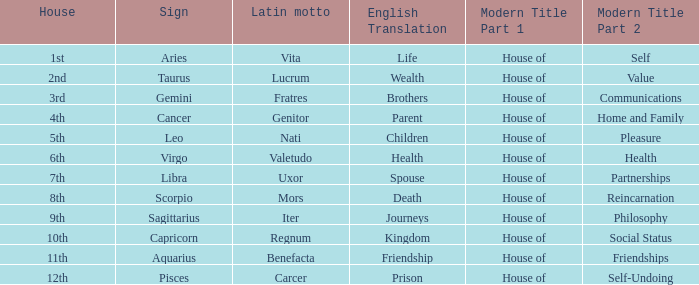Which sign has a modern house title of House of Partnerships? Libra. 